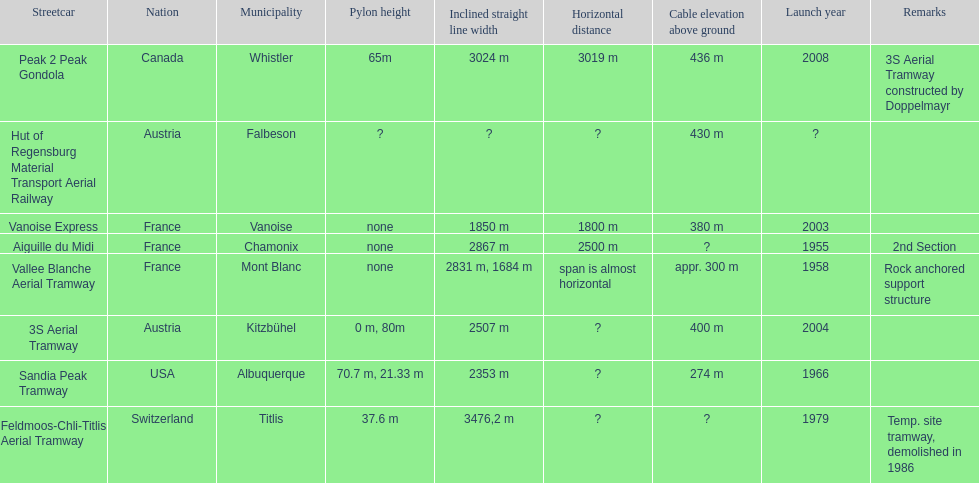How many aerial tramways are located in france? 3. 